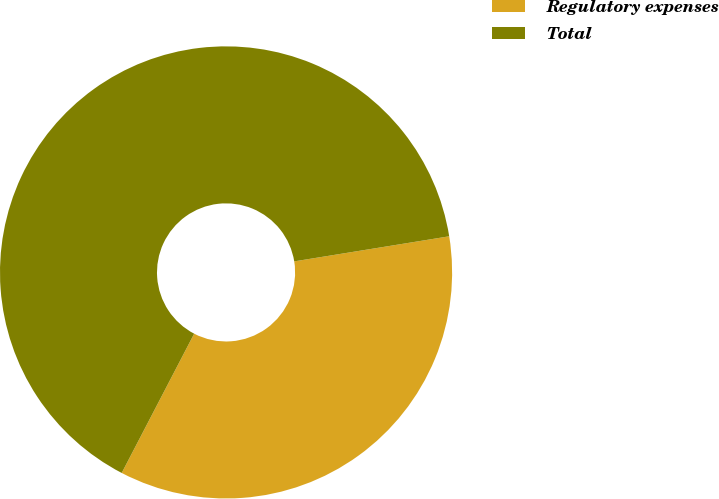<chart> <loc_0><loc_0><loc_500><loc_500><pie_chart><fcel>Regulatory expenses<fcel>Total<nl><fcel>35.19%<fcel>64.81%<nl></chart> 